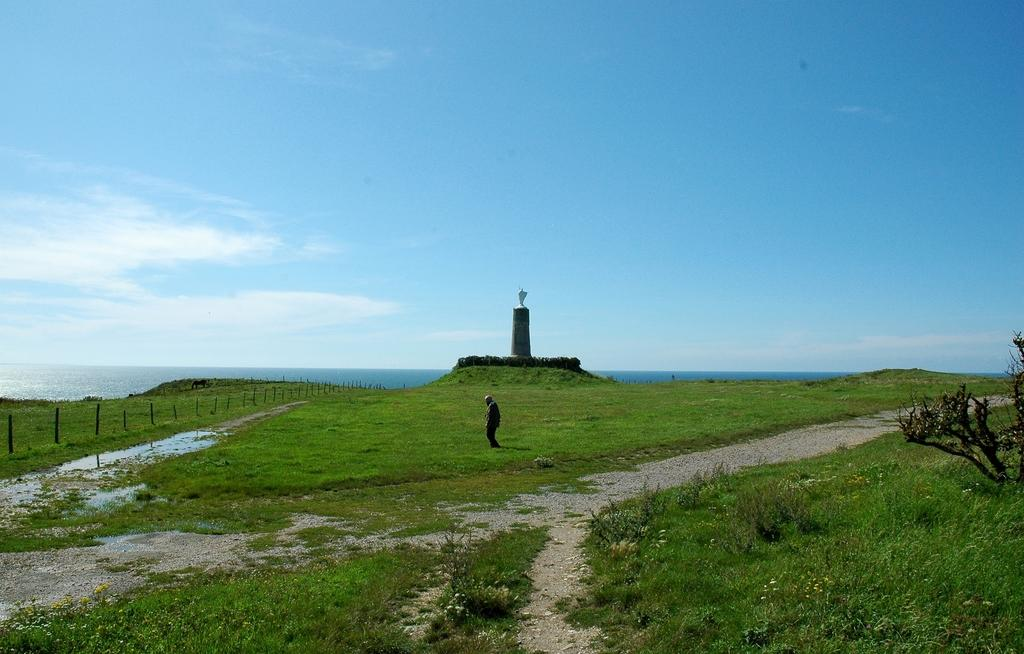What is the main subject in the center of the image? There is a person standing in the center of the image. What structure can be seen in the image with a statue on top? There is a tower with a statue in the image. What objects are present in the image that resemble long, thin vertical structures? There are poles in the image. What natural element is visible in the image? There is water visible in the image. What type of barrier can be seen in the image? There is a fence in the image. What type of vegetation is present in the image? There is grass in the image. What type of surface can be seen in the image that is meant for walking or traveling? There is a pathway in the image. How would you describe the sky in the image? The sky is visible and appears cloudy. What type of harmony can be heard in the image? There is no audible sound or harmony present in the image, as it is a still photograph. 